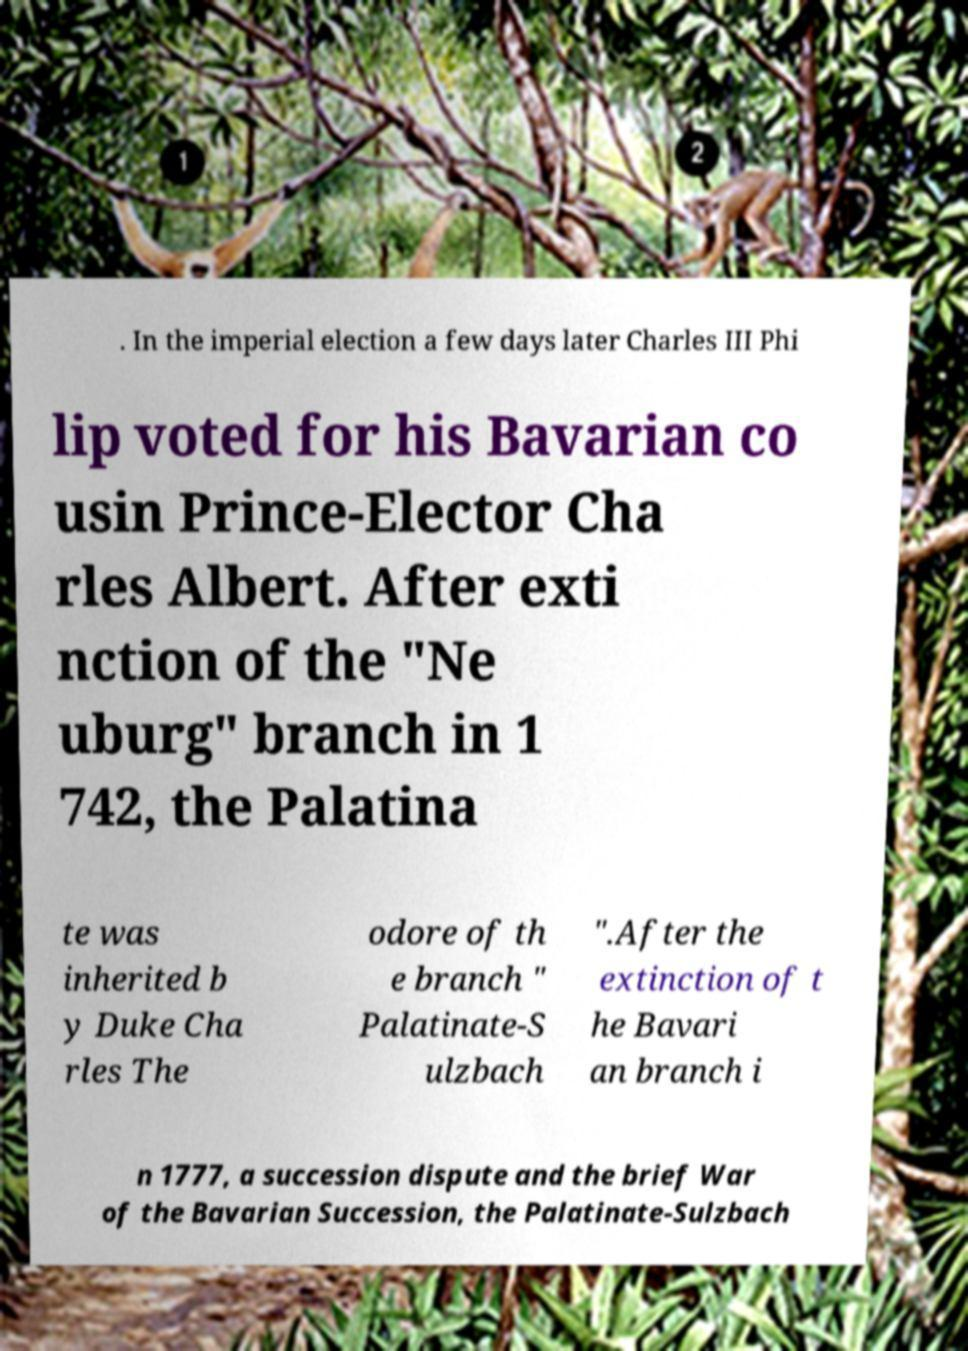I need the written content from this picture converted into text. Can you do that? . In the imperial election a few days later Charles III Phi lip voted for his Bavarian co usin Prince-Elector Cha rles Albert. After exti nction of the "Ne uburg" branch in 1 742, the Palatina te was inherited b y Duke Cha rles The odore of th e branch " Palatinate-S ulzbach ".After the extinction of t he Bavari an branch i n 1777, a succession dispute and the brief War of the Bavarian Succession, the Palatinate-Sulzbach 